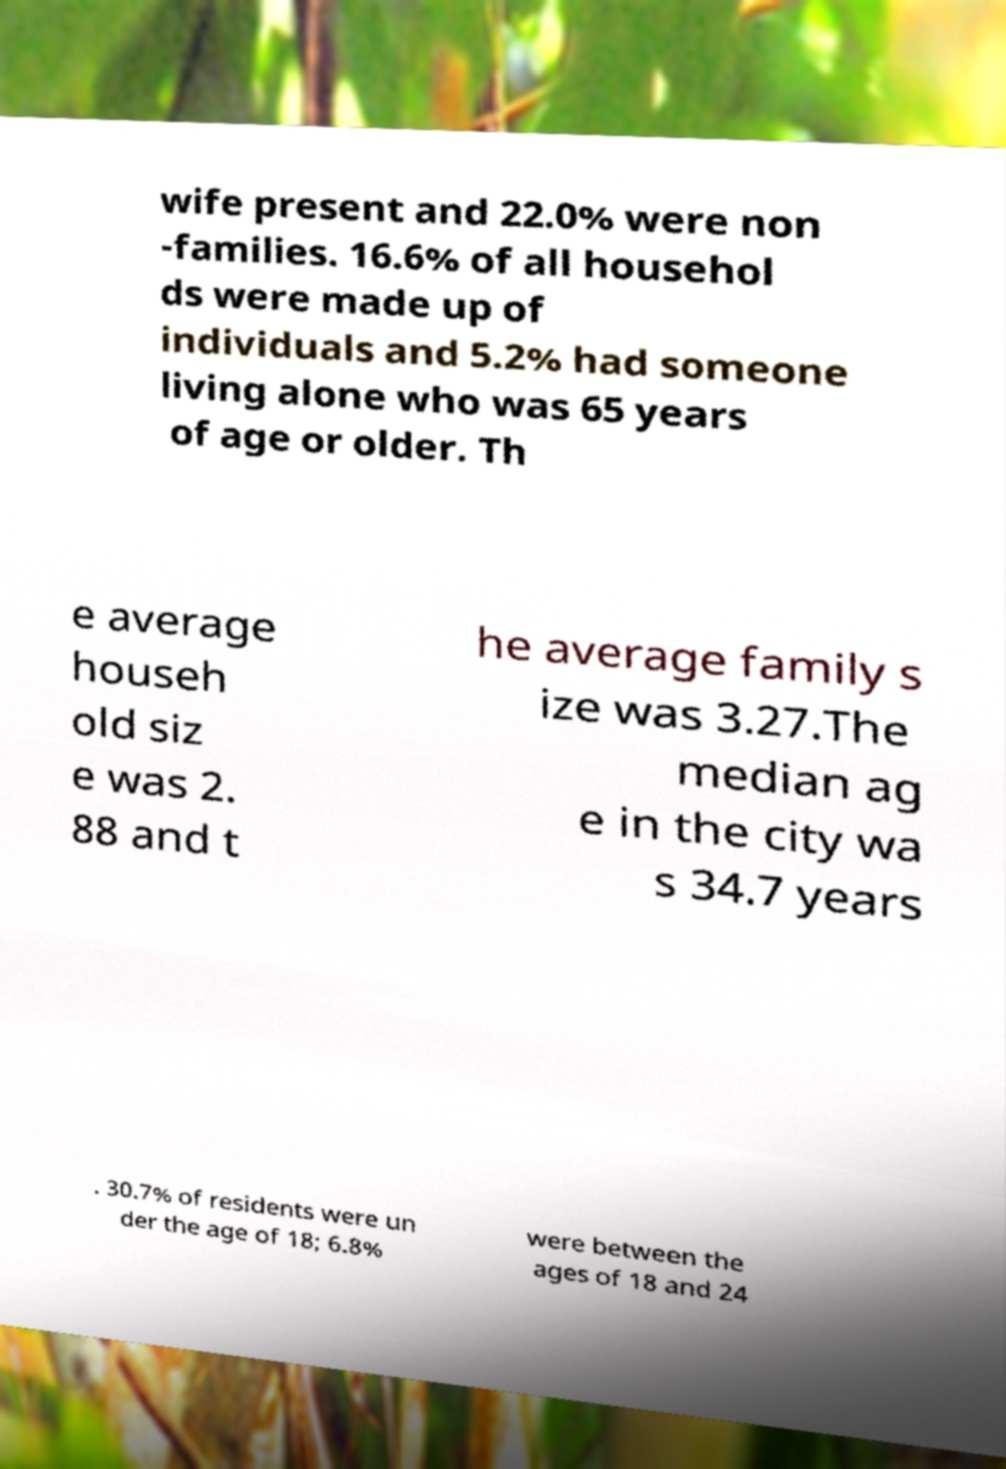Could you assist in decoding the text presented in this image and type it out clearly? wife present and 22.0% were non -families. 16.6% of all househol ds were made up of individuals and 5.2% had someone living alone who was 65 years of age or older. Th e average househ old siz e was 2. 88 and t he average family s ize was 3.27.The median ag e in the city wa s 34.7 years . 30.7% of residents were un der the age of 18; 6.8% were between the ages of 18 and 24 